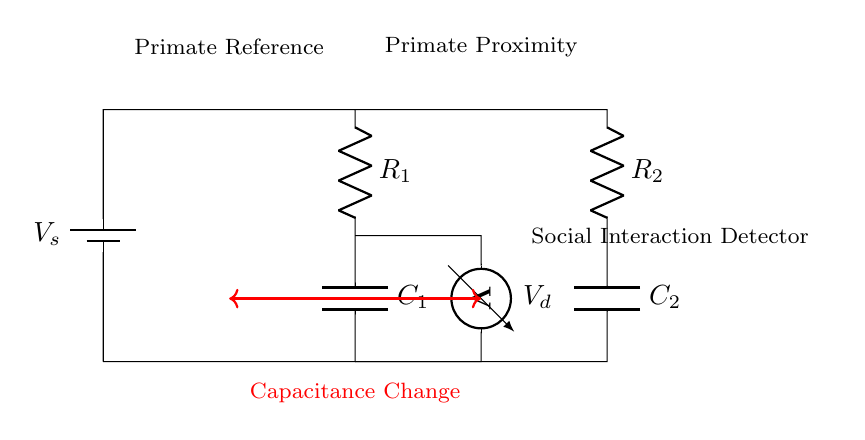What is the voltage source in the circuit? The voltage source is labeled as V_s, which indicates the electrical potential being supplied to the circuit.
Answer: V_s What are the resistance values in the circuit? The circuit has two resistors, R_1 and R_2, whose values are indicated next to their symbols. Specific values are not provided in the diagram, only their labels.
Answer: R_1 and R_2 How many capacitors are there in this circuit? There are two capacitors in the circuit, labeled as C_1 and C_2. They are connected in a configuration that forms part of the capacitance bridge.
Answer: Two What is the purpose of the voltmeter in the circuit? The voltmeter, labeled V_d, is used to measure the voltage difference between two points in the circuit, specifically at the point between the two resistors.
Answer: Measure voltage Which components detect social interactions according to the circuit? The circuit includes a section labeled "Social Interaction Detector," indicating that this part is responsible for detecting interactions, likely through analyzing capacitance changes.
Answer: Social Interaction Detector What does the red arrow indicate in the circuit diagram? The red arrow indicates that there is a capacitance change between the two sections of the circuit, represented by the connection of the two primates labeled in the diagram.
Answer: Capacitance Change How does the capacitance bridge relate to primate proximity? The capacitance bridge measures changes in capacitance caused by primate proximity; the closer the primates are, the greater the expected changes, thus providing data on their social interactions.
Answer: Capacitance change 